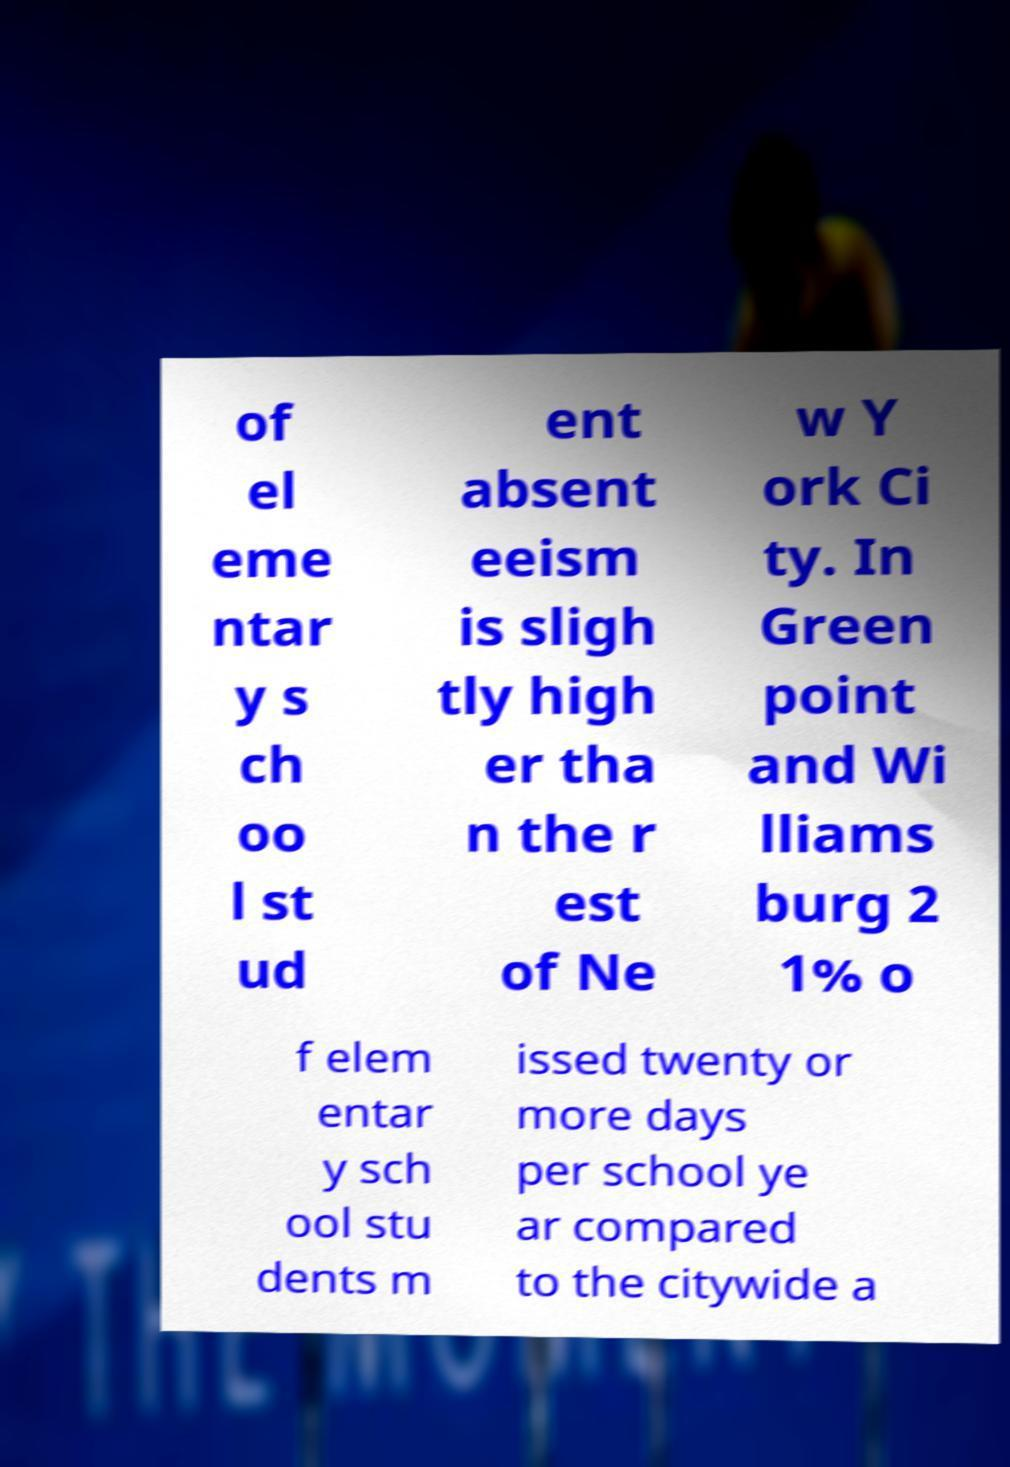Can you accurately transcribe the text from the provided image for me? of el eme ntar y s ch oo l st ud ent absent eeism is sligh tly high er tha n the r est of Ne w Y ork Ci ty. In Green point and Wi lliams burg 2 1% o f elem entar y sch ool stu dents m issed twenty or more days per school ye ar compared to the citywide a 